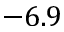<formula> <loc_0><loc_0><loc_500><loc_500>- 6 . 9</formula> 